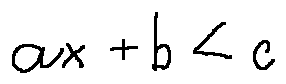<formula> <loc_0><loc_0><loc_500><loc_500>a x + b < c</formula> 